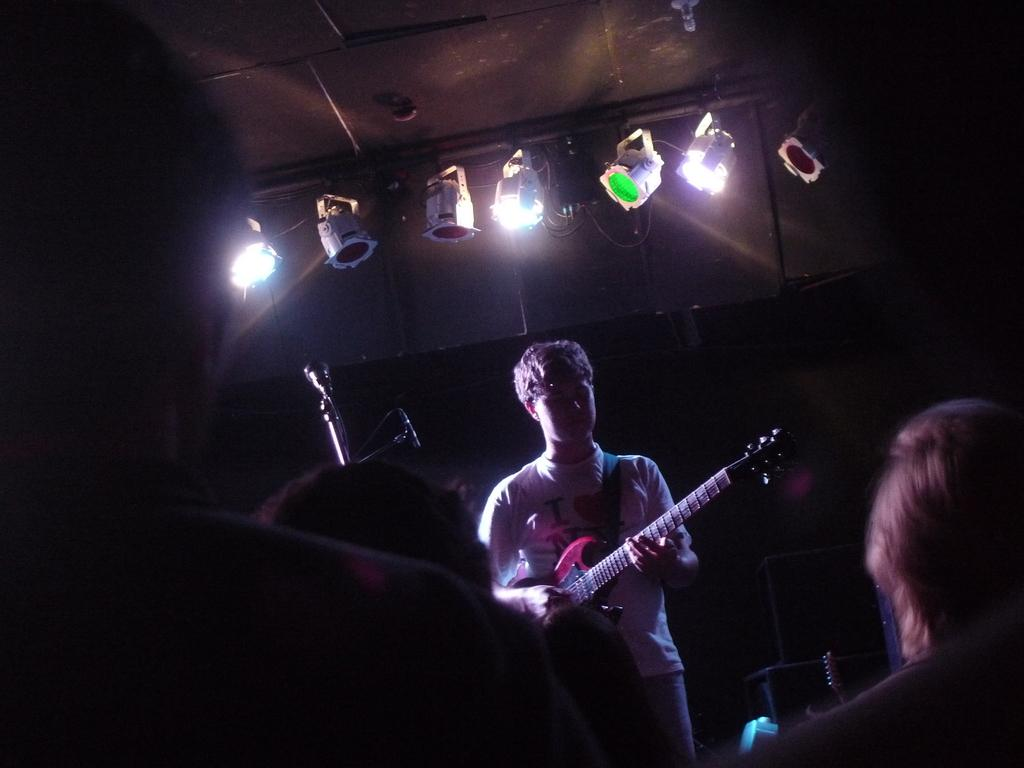What is the man in the image holding? The man is holding a guitar. How many people are in front of the man? There are three people in front of the man. What object is used for amplifying the man's voice in the image? There is a microphone in the image. What can be seen above the man that adds to the visual appeal of the scene? Colorful lights are visible above the man. What type of fruit is being sold by the man in the image? There is no fruit being sold in the image; the man is holding a guitar. How many brothers are visible in the image? There is no mention of brothers in the image; it only shows a man holding a guitar and three people in front of him. 